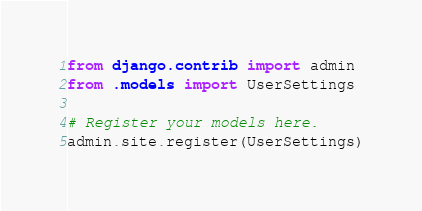Convert code to text. <code><loc_0><loc_0><loc_500><loc_500><_Python_>from django.contrib import admin
from .models import UserSettings

# Register your models here.
admin.site.register(UserSettings)
</code> 